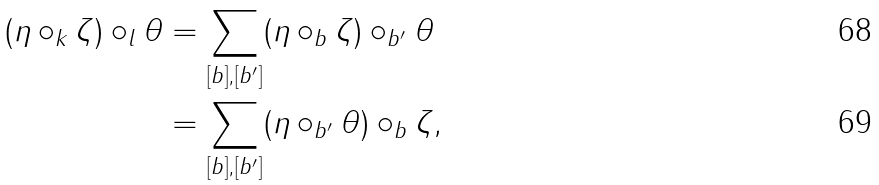<formula> <loc_0><loc_0><loc_500><loc_500>( \eta \circ _ { k } \zeta ) \circ _ { l } \theta & = \sum _ { [ b ] , [ b ^ { \prime } ] } ( \eta \circ _ { b } \zeta ) \circ _ { b ^ { \prime } } \theta \\ & = \sum _ { [ b ] , [ b ^ { \prime } ] } ( \eta \circ _ { b ^ { \prime } } \theta ) \circ _ { b } \zeta ,</formula> 